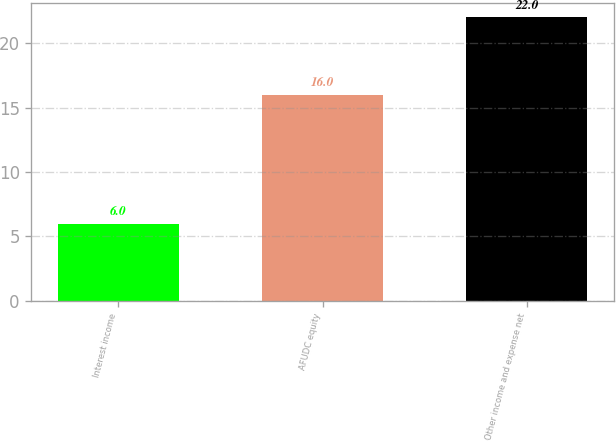<chart> <loc_0><loc_0><loc_500><loc_500><bar_chart><fcel>Interest income<fcel>AFUDC equity<fcel>Other income and expense net<nl><fcel>6<fcel>16<fcel>22<nl></chart> 